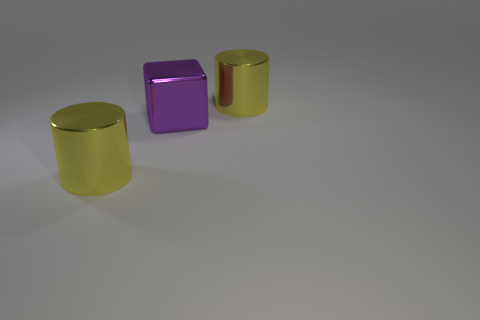Is there a big yellow shiny object on the left side of the yellow cylinder that is right of the large block?
Keep it short and to the point. Yes. What shape is the purple shiny thing on the right side of the yellow object that is to the left of the big purple thing?
Ensure brevity in your answer.  Cube. Are there fewer large purple objects than small brown rubber things?
Keep it short and to the point. No. Are there any yellow metal cylinders that have the same size as the purple thing?
Make the answer very short. Yes. Is the number of large metallic cylinders behind the big cube less than the number of yellow shiny objects?
Offer a very short reply. Yes. What size is the purple block?
Your response must be concise. Large. Are there any big yellow objects that are on the right side of the big purple cube that is in front of the thing behind the big purple object?
Your response must be concise. Yes. How many small things are purple shiny blocks or blue metallic cubes?
Your answer should be very brief. 0. Does the metal object left of the cube have the same shape as the big thing on the right side of the purple metal object?
Your response must be concise. Yes. What number of matte objects are either large blue objects or large purple blocks?
Offer a very short reply. 0. 